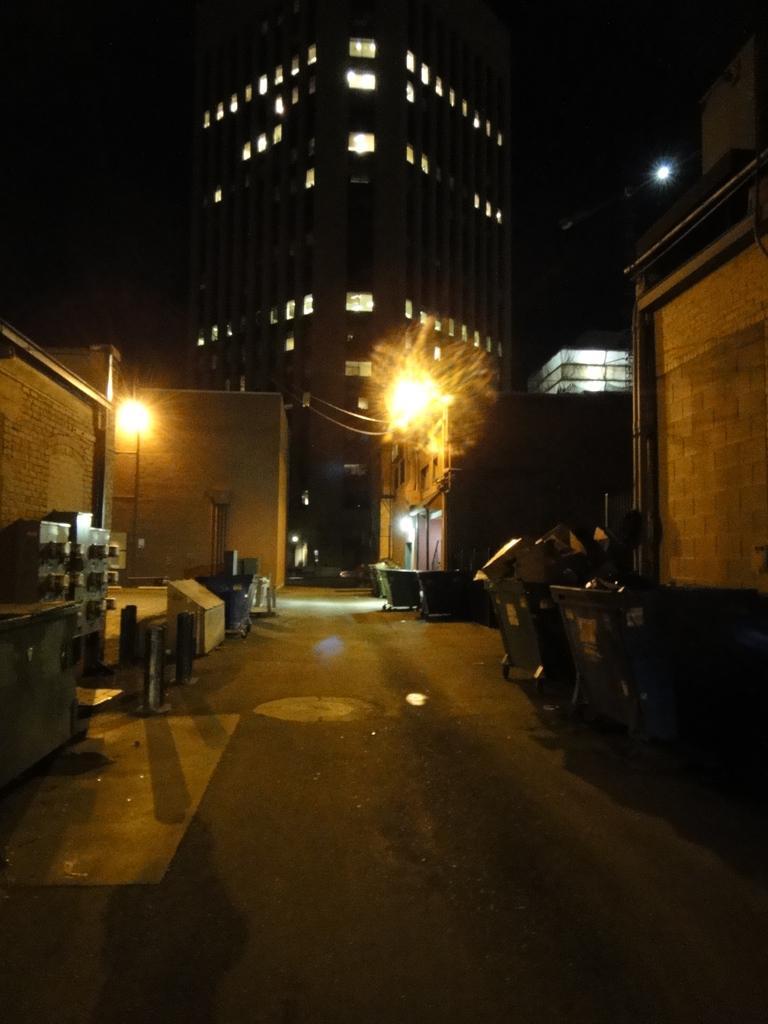In one or two sentences, can you explain what this image depicts? In this image, we can see some buildings. There are lights in the middle of the image. There are trash bins on the road. There is a panel board on the left side of the image. 